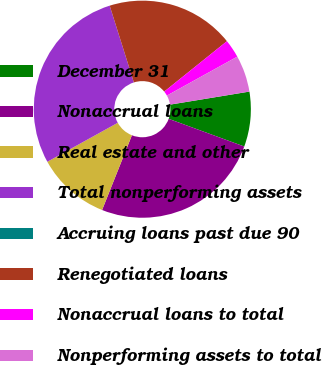Convert chart. <chart><loc_0><loc_0><loc_500><loc_500><pie_chart><fcel>December 31<fcel>Nonaccrual loans<fcel>Real estate and other<fcel>Total nonperforming assets<fcel>Accruing loans past due 90<fcel>Renegotiated loans<fcel>Nonaccrual loans to total<fcel>Nonperforming assets to total<nl><fcel>8.18%<fcel>25.46%<fcel>10.91%<fcel>28.19%<fcel>0.0%<fcel>19.09%<fcel>2.73%<fcel>5.45%<nl></chart> 